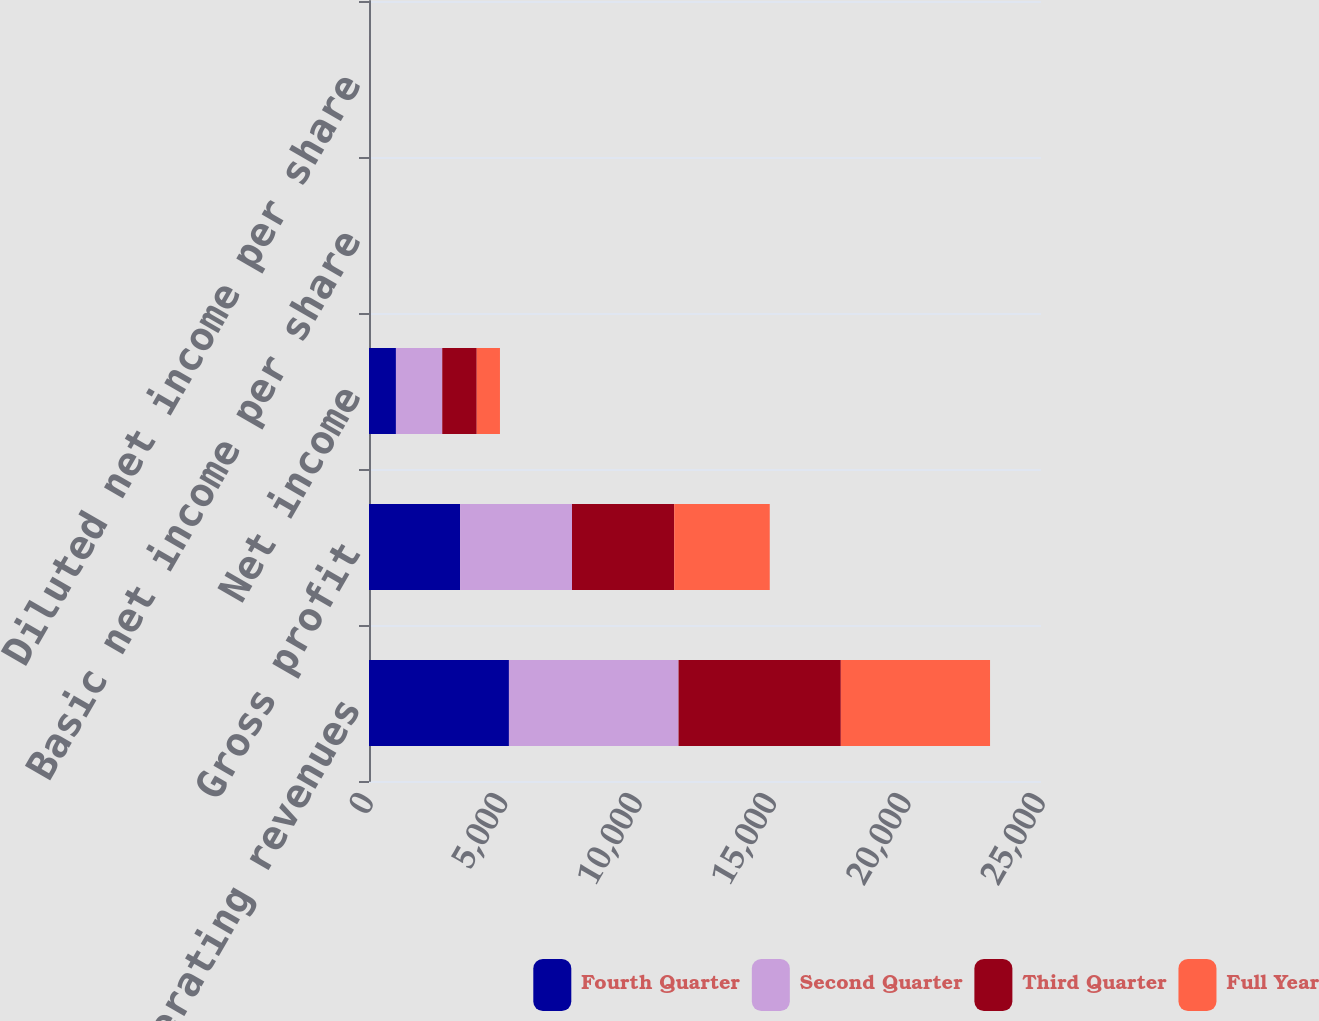<chart> <loc_0><loc_0><loc_500><loc_500><stacked_bar_chart><ecel><fcel>Net operating revenues<fcel>Gross profit<fcel>Net income<fcel>Basic net income per share<fcel>Diluted net income per share<nl><fcel>Fourth Quarter<fcel>5206<fcel>3388<fcel>1002<fcel>0.42<fcel>0.42<nl><fcel>Second Quarter<fcel>6310<fcel>4164<fcel>1723<fcel>0.72<fcel>0.72<nl><fcel>Third Quarter<fcel>6037<fcel>3802<fcel>1283<fcel>0.54<fcel>0.54<nl><fcel>Full Year<fcel>5551<fcel>3555<fcel>864<fcel>0.36<fcel>0.36<nl></chart> 